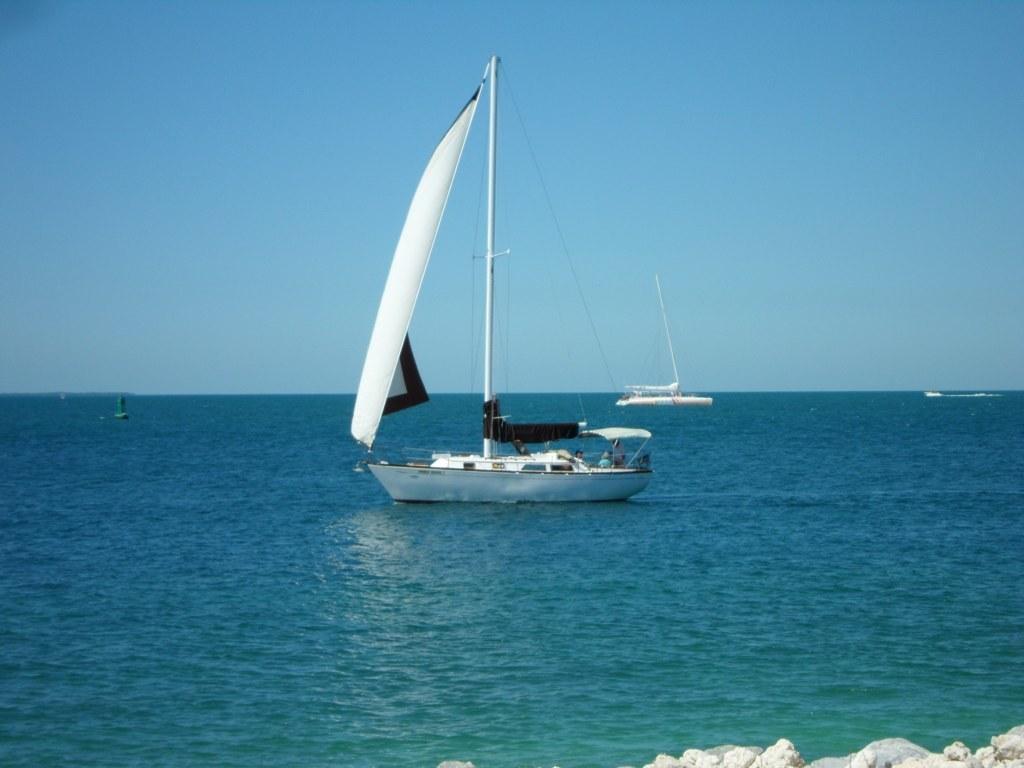Please provide a concise description of this image. In this image there are two ships in white color as we can see in the middle of this image. There is a sea in the bottom of this image and there is a sky on the top of this image. There are some stones in the bottom of this image. 